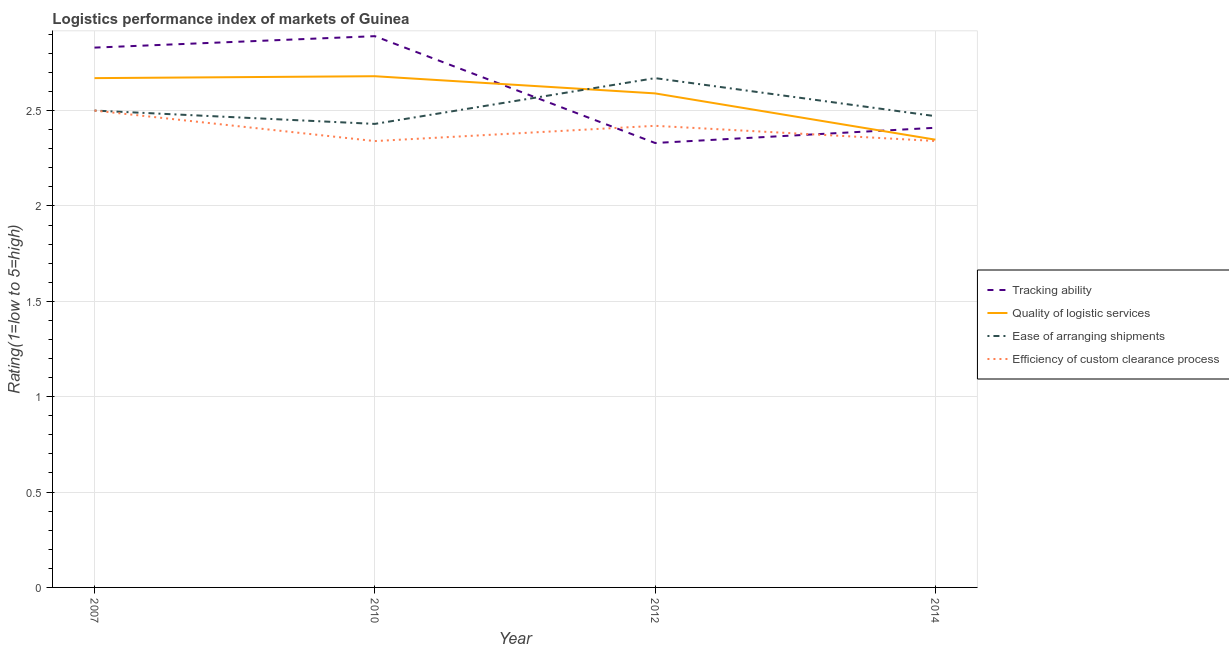How many different coloured lines are there?
Your response must be concise. 4. Is the number of lines equal to the number of legend labels?
Offer a terse response. Yes. What is the lpi rating of quality of logistic services in 2010?
Offer a very short reply. 2.68. Across all years, what is the maximum lpi rating of ease of arranging shipments?
Ensure brevity in your answer.  2.67. Across all years, what is the minimum lpi rating of tracking ability?
Offer a terse response. 2.33. In which year was the lpi rating of efficiency of custom clearance process maximum?
Provide a succinct answer. 2007. In which year was the lpi rating of efficiency of custom clearance process minimum?
Keep it short and to the point. 2010. What is the total lpi rating of tracking ability in the graph?
Make the answer very short. 10.46. What is the difference between the lpi rating of quality of logistic services in 2010 and that in 2012?
Ensure brevity in your answer.  0.09. What is the difference between the lpi rating of tracking ability in 2012 and the lpi rating of quality of logistic services in 2010?
Keep it short and to the point. -0.35. What is the average lpi rating of efficiency of custom clearance process per year?
Offer a very short reply. 2.4. In the year 2014, what is the difference between the lpi rating of tracking ability and lpi rating of ease of arranging shipments?
Ensure brevity in your answer.  -0.06. What is the ratio of the lpi rating of efficiency of custom clearance process in 2012 to that in 2014?
Your answer should be compact. 1.03. What is the difference between the highest and the second highest lpi rating of ease of arranging shipments?
Offer a terse response. 0.17. What is the difference between the highest and the lowest lpi rating of tracking ability?
Offer a very short reply. 0.56. Is the sum of the lpi rating of quality of logistic services in 2007 and 2012 greater than the maximum lpi rating of ease of arranging shipments across all years?
Provide a succinct answer. Yes. Is it the case that in every year, the sum of the lpi rating of efficiency of custom clearance process and lpi rating of tracking ability is greater than the sum of lpi rating of ease of arranging shipments and lpi rating of quality of logistic services?
Make the answer very short. Yes. Is it the case that in every year, the sum of the lpi rating of tracking ability and lpi rating of quality of logistic services is greater than the lpi rating of ease of arranging shipments?
Give a very brief answer. Yes. Does the lpi rating of tracking ability monotonically increase over the years?
Offer a terse response. No. Is the lpi rating of quality of logistic services strictly greater than the lpi rating of efficiency of custom clearance process over the years?
Your answer should be compact. Yes. Is the lpi rating of ease of arranging shipments strictly less than the lpi rating of tracking ability over the years?
Your answer should be compact. No. How many lines are there?
Make the answer very short. 4. What is the difference between two consecutive major ticks on the Y-axis?
Offer a terse response. 0.5. Are the values on the major ticks of Y-axis written in scientific E-notation?
Your answer should be compact. No. Does the graph contain any zero values?
Keep it short and to the point. No. Does the graph contain grids?
Provide a short and direct response. Yes. Where does the legend appear in the graph?
Keep it short and to the point. Center right. How many legend labels are there?
Ensure brevity in your answer.  4. How are the legend labels stacked?
Keep it short and to the point. Vertical. What is the title of the graph?
Your answer should be compact. Logistics performance index of markets of Guinea. What is the label or title of the X-axis?
Keep it short and to the point. Year. What is the label or title of the Y-axis?
Ensure brevity in your answer.  Rating(1=low to 5=high). What is the Rating(1=low to 5=high) of Tracking ability in 2007?
Make the answer very short. 2.83. What is the Rating(1=low to 5=high) of Quality of logistic services in 2007?
Give a very brief answer. 2.67. What is the Rating(1=low to 5=high) of Ease of arranging shipments in 2007?
Make the answer very short. 2.5. What is the Rating(1=low to 5=high) in Tracking ability in 2010?
Give a very brief answer. 2.89. What is the Rating(1=low to 5=high) in Quality of logistic services in 2010?
Keep it short and to the point. 2.68. What is the Rating(1=low to 5=high) of Ease of arranging shipments in 2010?
Offer a terse response. 2.43. What is the Rating(1=low to 5=high) in Efficiency of custom clearance process in 2010?
Keep it short and to the point. 2.34. What is the Rating(1=low to 5=high) in Tracking ability in 2012?
Provide a succinct answer. 2.33. What is the Rating(1=low to 5=high) of Quality of logistic services in 2012?
Keep it short and to the point. 2.59. What is the Rating(1=low to 5=high) of Ease of arranging shipments in 2012?
Your answer should be compact. 2.67. What is the Rating(1=low to 5=high) of Efficiency of custom clearance process in 2012?
Provide a succinct answer. 2.42. What is the Rating(1=low to 5=high) in Tracking ability in 2014?
Offer a terse response. 2.41. What is the Rating(1=low to 5=high) of Quality of logistic services in 2014?
Keep it short and to the point. 2.35. What is the Rating(1=low to 5=high) in Ease of arranging shipments in 2014?
Your answer should be compact. 2.47. What is the Rating(1=low to 5=high) of Efficiency of custom clearance process in 2014?
Give a very brief answer. 2.34. Across all years, what is the maximum Rating(1=low to 5=high) in Tracking ability?
Your answer should be very brief. 2.89. Across all years, what is the maximum Rating(1=low to 5=high) in Quality of logistic services?
Your response must be concise. 2.68. Across all years, what is the maximum Rating(1=low to 5=high) of Ease of arranging shipments?
Give a very brief answer. 2.67. Across all years, what is the maximum Rating(1=low to 5=high) in Efficiency of custom clearance process?
Your answer should be compact. 2.5. Across all years, what is the minimum Rating(1=low to 5=high) of Tracking ability?
Ensure brevity in your answer.  2.33. Across all years, what is the minimum Rating(1=low to 5=high) in Quality of logistic services?
Keep it short and to the point. 2.35. Across all years, what is the minimum Rating(1=low to 5=high) of Ease of arranging shipments?
Ensure brevity in your answer.  2.43. Across all years, what is the minimum Rating(1=low to 5=high) in Efficiency of custom clearance process?
Your answer should be compact. 2.34. What is the total Rating(1=low to 5=high) in Tracking ability in the graph?
Provide a short and direct response. 10.46. What is the total Rating(1=low to 5=high) of Quality of logistic services in the graph?
Provide a succinct answer. 10.29. What is the total Rating(1=low to 5=high) in Ease of arranging shipments in the graph?
Offer a very short reply. 10.07. What is the total Rating(1=low to 5=high) of Efficiency of custom clearance process in the graph?
Offer a terse response. 9.6. What is the difference between the Rating(1=low to 5=high) in Tracking ability in 2007 and that in 2010?
Your response must be concise. -0.06. What is the difference between the Rating(1=low to 5=high) in Quality of logistic services in 2007 and that in 2010?
Ensure brevity in your answer.  -0.01. What is the difference between the Rating(1=low to 5=high) of Ease of arranging shipments in 2007 and that in 2010?
Give a very brief answer. 0.07. What is the difference between the Rating(1=low to 5=high) in Efficiency of custom clearance process in 2007 and that in 2010?
Ensure brevity in your answer.  0.16. What is the difference between the Rating(1=low to 5=high) in Tracking ability in 2007 and that in 2012?
Ensure brevity in your answer.  0.5. What is the difference between the Rating(1=low to 5=high) of Quality of logistic services in 2007 and that in 2012?
Provide a short and direct response. 0.08. What is the difference between the Rating(1=low to 5=high) of Ease of arranging shipments in 2007 and that in 2012?
Give a very brief answer. -0.17. What is the difference between the Rating(1=low to 5=high) in Tracking ability in 2007 and that in 2014?
Make the answer very short. 0.42. What is the difference between the Rating(1=low to 5=high) of Quality of logistic services in 2007 and that in 2014?
Offer a very short reply. 0.32. What is the difference between the Rating(1=low to 5=high) of Ease of arranging shipments in 2007 and that in 2014?
Your answer should be very brief. 0.03. What is the difference between the Rating(1=low to 5=high) in Efficiency of custom clearance process in 2007 and that in 2014?
Give a very brief answer. 0.16. What is the difference between the Rating(1=low to 5=high) in Tracking ability in 2010 and that in 2012?
Keep it short and to the point. 0.56. What is the difference between the Rating(1=low to 5=high) in Quality of logistic services in 2010 and that in 2012?
Your answer should be very brief. 0.09. What is the difference between the Rating(1=low to 5=high) in Ease of arranging shipments in 2010 and that in 2012?
Your answer should be very brief. -0.24. What is the difference between the Rating(1=low to 5=high) in Efficiency of custom clearance process in 2010 and that in 2012?
Offer a terse response. -0.08. What is the difference between the Rating(1=low to 5=high) in Tracking ability in 2010 and that in 2014?
Give a very brief answer. 0.48. What is the difference between the Rating(1=low to 5=high) in Quality of logistic services in 2010 and that in 2014?
Keep it short and to the point. 0.33. What is the difference between the Rating(1=low to 5=high) in Ease of arranging shipments in 2010 and that in 2014?
Your answer should be very brief. -0.04. What is the difference between the Rating(1=low to 5=high) in Efficiency of custom clearance process in 2010 and that in 2014?
Ensure brevity in your answer.  -0. What is the difference between the Rating(1=low to 5=high) in Tracking ability in 2012 and that in 2014?
Make the answer very short. -0.08. What is the difference between the Rating(1=low to 5=high) in Quality of logistic services in 2012 and that in 2014?
Make the answer very short. 0.24. What is the difference between the Rating(1=low to 5=high) of Ease of arranging shipments in 2012 and that in 2014?
Your answer should be very brief. 0.2. What is the difference between the Rating(1=low to 5=high) of Efficiency of custom clearance process in 2012 and that in 2014?
Make the answer very short. 0.08. What is the difference between the Rating(1=low to 5=high) in Tracking ability in 2007 and the Rating(1=low to 5=high) in Quality of logistic services in 2010?
Keep it short and to the point. 0.15. What is the difference between the Rating(1=low to 5=high) in Tracking ability in 2007 and the Rating(1=low to 5=high) in Ease of arranging shipments in 2010?
Offer a terse response. 0.4. What is the difference between the Rating(1=low to 5=high) in Tracking ability in 2007 and the Rating(1=low to 5=high) in Efficiency of custom clearance process in 2010?
Ensure brevity in your answer.  0.49. What is the difference between the Rating(1=low to 5=high) of Quality of logistic services in 2007 and the Rating(1=low to 5=high) of Ease of arranging shipments in 2010?
Make the answer very short. 0.24. What is the difference between the Rating(1=low to 5=high) of Quality of logistic services in 2007 and the Rating(1=low to 5=high) of Efficiency of custom clearance process in 2010?
Provide a succinct answer. 0.33. What is the difference between the Rating(1=low to 5=high) of Ease of arranging shipments in 2007 and the Rating(1=low to 5=high) of Efficiency of custom clearance process in 2010?
Make the answer very short. 0.16. What is the difference between the Rating(1=low to 5=high) in Tracking ability in 2007 and the Rating(1=low to 5=high) in Quality of logistic services in 2012?
Offer a terse response. 0.24. What is the difference between the Rating(1=low to 5=high) in Tracking ability in 2007 and the Rating(1=low to 5=high) in Ease of arranging shipments in 2012?
Your answer should be compact. 0.16. What is the difference between the Rating(1=low to 5=high) of Tracking ability in 2007 and the Rating(1=low to 5=high) of Efficiency of custom clearance process in 2012?
Offer a very short reply. 0.41. What is the difference between the Rating(1=low to 5=high) of Quality of logistic services in 2007 and the Rating(1=low to 5=high) of Ease of arranging shipments in 2012?
Ensure brevity in your answer.  0. What is the difference between the Rating(1=low to 5=high) of Tracking ability in 2007 and the Rating(1=low to 5=high) of Quality of logistic services in 2014?
Provide a succinct answer. 0.48. What is the difference between the Rating(1=low to 5=high) of Tracking ability in 2007 and the Rating(1=low to 5=high) of Ease of arranging shipments in 2014?
Make the answer very short. 0.36. What is the difference between the Rating(1=low to 5=high) in Tracking ability in 2007 and the Rating(1=low to 5=high) in Efficiency of custom clearance process in 2014?
Provide a succinct answer. 0.49. What is the difference between the Rating(1=low to 5=high) of Quality of logistic services in 2007 and the Rating(1=low to 5=high) of Ease of arranging shipments in 2014?
Offer a terse response. 0.2. What is the difference between the Rating(1=low to 5=high) in Quality of logistic services in 2007 and the Rating(1=low to 5=high) in Efficiency of custom clearance process in 2014?
Give a very brief answer. 0.33. What is the difference between the Rating(1=low to 5=high) in Ease of arranging shipments in 2007 and the Rating(1=low to 5=high) in Efficiency of custom clearance process in 2014?
Keep it short and to the point. 0.16. What is the difference between the Rating(1=low to 5=high) in Tracking ability in 2010 and the Rating(1=low to 5=high) in Quality of logistic services in 2012?
Make the answer very short. 0.3. What is the difference between the Rating(1=low to 5=high) in Tracking ability in 2010 and the Rating(1=low to 5=high) in Ease of arranging shipments in 2012?
Provide a short and direct response. 0.22. What is the difference between the Rating(1=low to 5=high) of Tracking ability in 2010 and the Rating(1=low to 5=high) of Efficiency of custom clearance process in 2012?
Provide a short and direct response. 0.47. What is the difference between the Rating(1=low to 5=high) in Quality of logistic services in 2010 and the Rating(1=low to 5=high) in Ease of arranging shipments in 2012?
Offer a very short reply. 0.01. What is the difference between the Rating(1=low to 5=high) of Quality of logistic services in 2010 and the Rating(1=low to 5=high) of Efficiency of custom clearance process in 2012?
Your response must be concise. 0.26. What is the difference between the Rating(1=low to 5=high) in Tracking ability in 2010 and the Rating(1=low to 5=high) in Quality of logistic services in 2014?
Provide a succinct answer. 0.54. What is the difference between the Rating(1=low to 5=high) of Tracking ability in 2010 and the Rating(1=low to 5=high) of Ease of arranging shipments in 2014?
Make the answer very short. 0.42. What is the difference between the Rating(1=low to 5=high) of Tracking ability in 2010 and the Rating(1=low to 5=high) of Efficiency of custom clearance process in 2014?
Make the answer very short. 0.55. What is the difference between the Rating(1=low to 5=high) of Quality of logistic services in 2010 and the Rating(1=low to 5=high) of Ease of arranging shipments in 2014?
Provide a succinct answer. 0.21. What is the difference between the Rating(1=low to 5=high) of Quality of logistic services in 2010 and the Rating(1=low to 5=high) of Efficiency of custom clearance process in 2014?
Make the answer very short. 0.34. What is the difference between the Rating(1=low to 5=high) in Ease of arranging shipments in 2010 and the Rating(1=low to 5=high) in Efficiency of custom clearance process in 2014?
Ensure brevity in your answer.  0.09. What is the difference between the Rating(1=low to 5=high) of Tracking ability in 2012 and the Rating(1=low to 5=high) of Quality of logistic services in 2014?
Your response must be concise. -0.02. What is the difference between the Rating(1=low to 5=high) in Tracking ability in 2012 and the Rating(1=low to 5=high) in Ease of arranging shipments in 2014?
Ensure brevity in your answer.  -0.14. What is the difference between the Rating(1=low to 5=high) of Tracking ability in 2012 and the Rating(1=low to 5=high) of Efficiency of custom clearance process in 2014?
Ensure brevity in your answer.  -0.01. What is the difference between the Rating(1=low to 5=high) in Quality of logistic services in 2012 and the Rating(1=low to 5=high) in Ease of arranging shipments in 2014?
Provide a short and direct response. 0.12. What is the difference between the Rating(1=low to 5=high) in Quality of logistic services in 2012 and the Rating(1=low to 5=high) in Efficiency of custom clearance process in 2014?
Offer a very short reply. 0.25. What is the difference between the Rating(1=low to 5=high) in Ease of arranging shipments in 2012 and the Rating(1=low to 5=high) in Efficiency of custom clearance process in 2014?
Your answer should be compact. 0.33. What is the average Rating(1=low to 5=high) of Tracking ability per year?
Your answer should be compact. 2.62. What is the average Rating(1=low to 5=high) of Quality of logistic services per year?
Your answer should be compact. 2.57. What is the average Rating(1=low to 5=high) of Ease of arranging shipments per year?
Your answer should be very brief. 2.52. What is the average Rating(1=low to 5=high) in Efficiency of custom clearance process per year?
Ensure brevity in your answer.  2.4. In the year 2007, what is the difference between the Rating(1=low to 5=high) in Tracking ability and Rating(1=low to 5=high) in Quality of logistic services?
Provide a succinct answer. 0.16. In the year 2007, what is the difference between the Rating(1=low to 5=high) of Tracking ability and Rating(1=low to 5=high) of Ease of arranging shipments?
Offer a terse response. 0.33. In the year 2007, what is the difference between the Rating(1=low to 5=high) of Tracking ability and Rating(1=low to 5=high) of Efficiency of custom clearance process?
Provide a short and direct response. 0.33. In the year 2007, what is the difference between the Rating(1=low to 5=high) in Quality of logistic services and Rating(1=low to 5=high) in Ease of arranging shipments?
Your response must be concise. 0.17. In the year 2007, what is the difference between the Rating(1=low to 5=high) in Quality of logistic services and Rating(1=low to 5=high) in Efficiency of custom clearance process?
Keep it short and to the point. 0.17. In the year 2007, what is the difference between the Rating(1=low to 5=high) in Ease of arranging shipments and Rating(1=low to 5=high) in Efficiency of custom clearance process?
Your response must be concise. 0. In the year 2010, what is the difference between the Rating(1=low to 5=high) in Tracking ability and Rating(1=low to 5=high) in Quality of logistic services?
Your answer should be compact. 0.21. In the year 2010, what is the difference between the Rating(1=low to 5=high) in Tracking ability and Rating(1=low to 5=high) in Ease of arranging shipments?
Ensure brevity in your answer.  0.46. In the year 2010, what is the difference between the Rating(1=low to 5=high) of Tracking ability and Rating(1=low to 5=high) of Efficiency of custom clearance process?
Make the answer very short. 0.55. In the year 2010, what is the difference between the Rating(1=low to 5=high) of Quality of logistic services and Rating(1=low to 5=high) of Efficiency of custom clearance process?
Provide a short and direct response. 0.34. In the year 2010, what is the difference between the Rating(1=low to 5=high) in Ease of arranging shipments and Rating(1=low to 5=high) in Efficiency of custom clearance process?
Offer a very short reply. 0.09. In the year 2012, what is the difference between the Rating(1=low to 5=high) of Tracking ability and Rating(1=low to 5=high) of Quality of logistic services?
Provide a short and direct response. -0.26. In the year 2012, what is the difference between the Rating(1=low to 5=high) of Tracking ability and Rating(1=low to 5=high) of Ease of arranging shipments?
Your answer should be compact. -0.34. In the year 2012, what is the difference between the Rating(1=low to 5=high) of Tracking ability and Rating(1=low to 5=high) of Efficiency of custom clearance process?
Offer a terse response. -0.09. In the year 2012, what is the difference between the Rating(1=low to 5=high) in Quality of logistic services and Rating(1=low to 5=high) in Ease of arranging shipments?
Make the answer very short. -0.08. In the year 2012, what is the difference between the Rating(1=low to 5=high) in Quality of logistic services and Rating(1=low to 5=high) in Efficiency of custom clearance process?
Your answer should be compact. 0.17. In the year 2012, what is the difference between the Rating(1=low to 5=high) in Ease of arranging shipments and Rating(1=low to 5=high) in Efficiency of custom clearance process?
Offer a very short reply. 0.25. In the year 2014, what is the difference between the Rating(1=low to 5=high) of Tracking ability and Rating(1=low to 5=high) of Quality of logistic services?
Give a very brief answer. 0.06. In the year 2014, what is the difference between the Rating(1=low to 5=high) of Tracking ability and Rating(1=low to 5=high) of Ease of arranging shipments?
Provide a short and direct response. -0.06. In the year 2014, what is the difference between the Rating(1=low to 5=high) in Tracking ability and Rating(1=low to 5=high) in Efficiency of custom clearance process?
Your answer should be compact. 0.07. In the year 2014, what is the difference between the Rating(1=low to 5=high) in Quality of logistic services and Rating(1=low to 5=high) in Ease of arranging shipments?
Offer a terse response. -0.12. In the year 2014, what is the difference between the Rating(1=low to 5=high) of Quality of logistic services and Rating(1=low to 5=high) of Efficiency of custom clearance process?
Your answer should be very brief. 0.01. In the year 2014, what is the difference between the Rating(1=low to 5=high) of Ease of arranging shipments and Rating(1=low to 5=high) of Efficiency of custom clearance process?
Keep it short and to the point. 0.13. What is the ratio of the Rating(1=low to 5=high) in Tracking ability in 2007 to that in 2010?
Your response must be concise. 0.98. What is the ratio of the Rating(1=low to 5=high) of Quality of logistic services in 2007 to that in 2010?
Give a very brief answer. 1. What is the ratio of the Rating(1=low to 5=high) in Ease of arranging shipments in 2007 to that in 2010?
Provide a short and direct response. 1.03. What is the ratio of the Rating(1=low to 5=high) in Efficiency of custom clearance process in 2007 to that in 2010?
Provide a succinct answer. 1.07. What is the ratio of the Rating(1=low to 5=high) of Tracking ability in 2007 to that in 2012?
Provide a short and direct response. 1.21. What is the ratio of the Rating(1=low to 5=high) of Quality of logistic services in 2007 to that in 2012?
Keep it short and to the point. 1.03. What is the ratio of the Rating(1=low to 5=high) of Ease of arranging shipments in 2007 to that in 2012?
Give a very brief answer. 0.94. What is the ratio of the Rating(1=low to 5=high) of Efficiency of custom clearance process in 2007 to that in 2012?
Ensure brevity in your answer.  1.03. What is the ratio of the Rating(1=low to 5=high) of Tracking ability in 2007 to that in 2014?
Your answer should be compact. 1.17. What is the ratio of the Rating(1=low to 5=high) in Quality of logistic services in 2007 to that in 2014?
Provide a succinct answer. 1.14. What is the ratio of the Rating(1=low to 5=high) in Ease of arranging shipments in 2007 to that in 2014?
Provide a succinct answer. 1.01. What is the ratio of the Rating(1=low to 5=high) of Efficiency of custom clearance process in 2007 to that in 2014?
Keep it short and to the point. 1.07. What is the ratio of the Rating(1=low to 5=high) in Tracking ability in 2010 to that in 2012?
Provide a short and direct response. 1.24. What is the ratio of the Rating(1=low to 5=high) of Quality of logistic services in 2010 to that in 2012?
Keep it short and to the point. 1.03. What is the ratio of the Rating(1=low to 5=high) of Ease of arranging shipments in 2010 to that in 2012?
Provide a short and direct response. 0.91. What is the ratio of the Rating(1=low to 5=high) of Efficiency of custom clearance process in 2010 to that in 2012?
Your response must be concise. 0.97. What is the ratio of the Rating(1=low to 5=high) in Tracking ability in 2010 to that in 2014?
Offer a terse response. 1.2. What is the ratio of the Rating(1=low to 5=high) in Quality of logistic services in 2010 to that in 2014?
Provide a short and direct response. 1.14. What is the ratio of the Rating(1=low to 5=high) of Ease of arranging shipments in 2010 to that in 2014?
Ensure brevity in your answer.  0.98. What is the ratio of the Rating(1=low to 5=high) in Tracking ability in 2012 to that in 2014?
Your answer should be compact. 0.97. What is the ratio of the Rating(1=low to 5=high) of Quality of logistic services in 2012 to that in 2014?
Provide a short and direct response. 1.1. What is the ratio of the Rating(1=low to 5=high) of Ease of arranging shipments in 2012 to that in 2014?
Your answer should be very brief. 1.08. What is the ratio of the Rating(1=low to 5=high) in Efficiency of custom clearance process in 2012 to that in 2014?
Your answer should be compact. 1.03. What is the difference between the highest and the second highest Rating(1=low to 5=high) in Tracking ability?
Offer a very short reply. 0.06. What is the difference between the highest and the second highest Rating(1=low to 5=high) of Ease of arranging shipments?
Provide a short and direct response. 0.17. What is the difference between the highest and the lowest Rating(1=low to 5=high) in Tracking ability?
Your answer should be compact. 0.56. What is the difference between the highest and the lowest Rating(1=low to 5=high) of Quality of logistic services?
Provide a succinct answer. 0.33. What is the difference between the highest and the lowest Rating(1=low to 5=high) in Ease of arranging shipments?
Ensure brevity in your answer.  0.24. What is the difference between the highest and the lowest Rating(1=low to 5=high) in Efficiency of custom clearance process?
Provide a succinct answer. 0.16. 